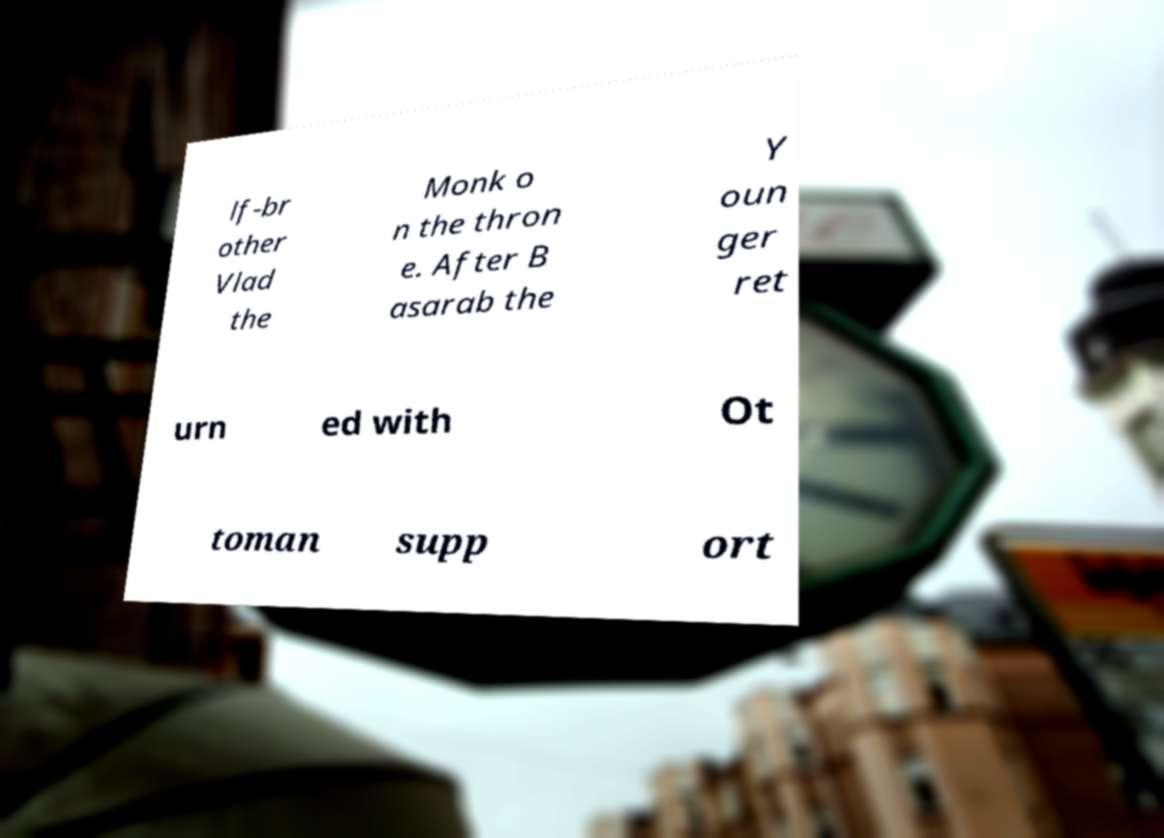Could you assist in decoding the text presented in this image and type it out clearly? lf-br other Vlad the Monk o n the thron e. After B asarab the Y oun ger ret urn ed with Ot toman supp ort 